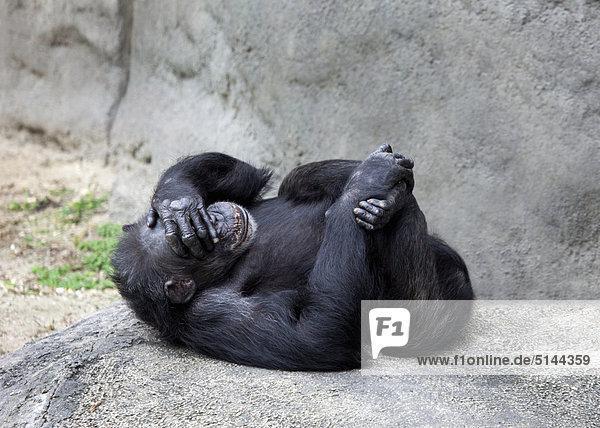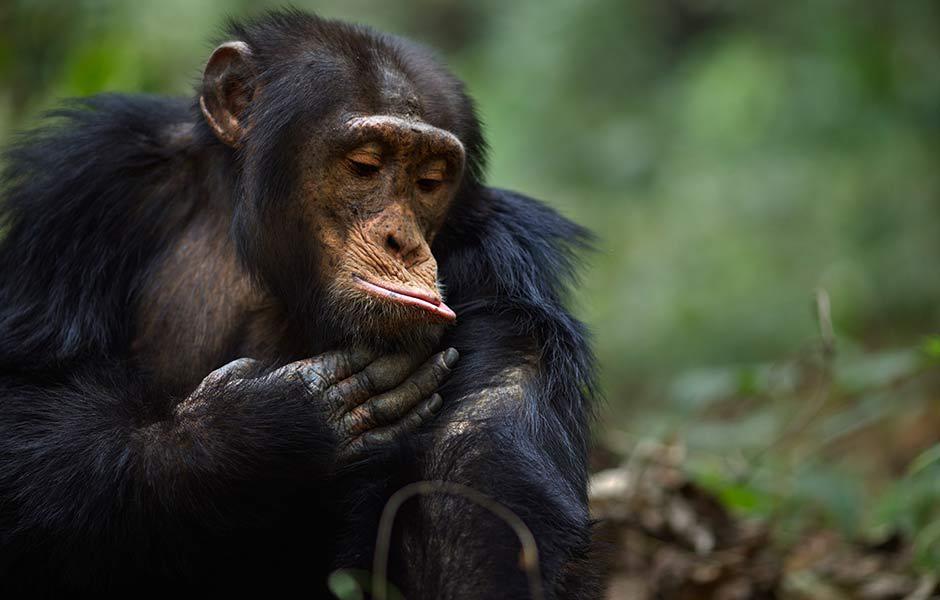The first image is the image on the left, the second image is the image on the right. Considering the images on both sides, is "In one of the images there are exactly two chimpanzees laying down near each other.." valid? Answer yes or no. No. The first image is the image on the left, the second image is the image on the right. For the images displayed, is the sentence "Two primates are lying down in one of the images." factually correct? Answer yes or no. No. 